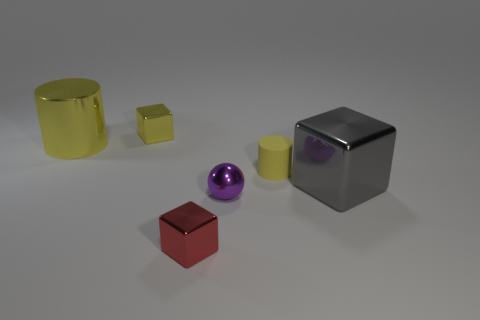Subtract all yellow blocks. How many blocks are left? 2 Subtract all gray cubes. How many cubes are left? 2 Add 1 large red cubes. How many objects exist? 7 Subtract 1 cubes. How many cubes are left? 2 Subtract all cylinders. How many objects are left? 4 Subtract all yellow blocks. Subtract all cyan spheres. How many blocks are left? 2 Subtract all blue cylinders. How many green blocks are left? 0 Subtract all red objects. Subtract all small blocks. How many objects are left? 3 Add 2 tiny yellow rubber objects. How many tiny yellow rubber objects are left? 3 Add 6 small metal balls. How many small metal balls exist? 7 